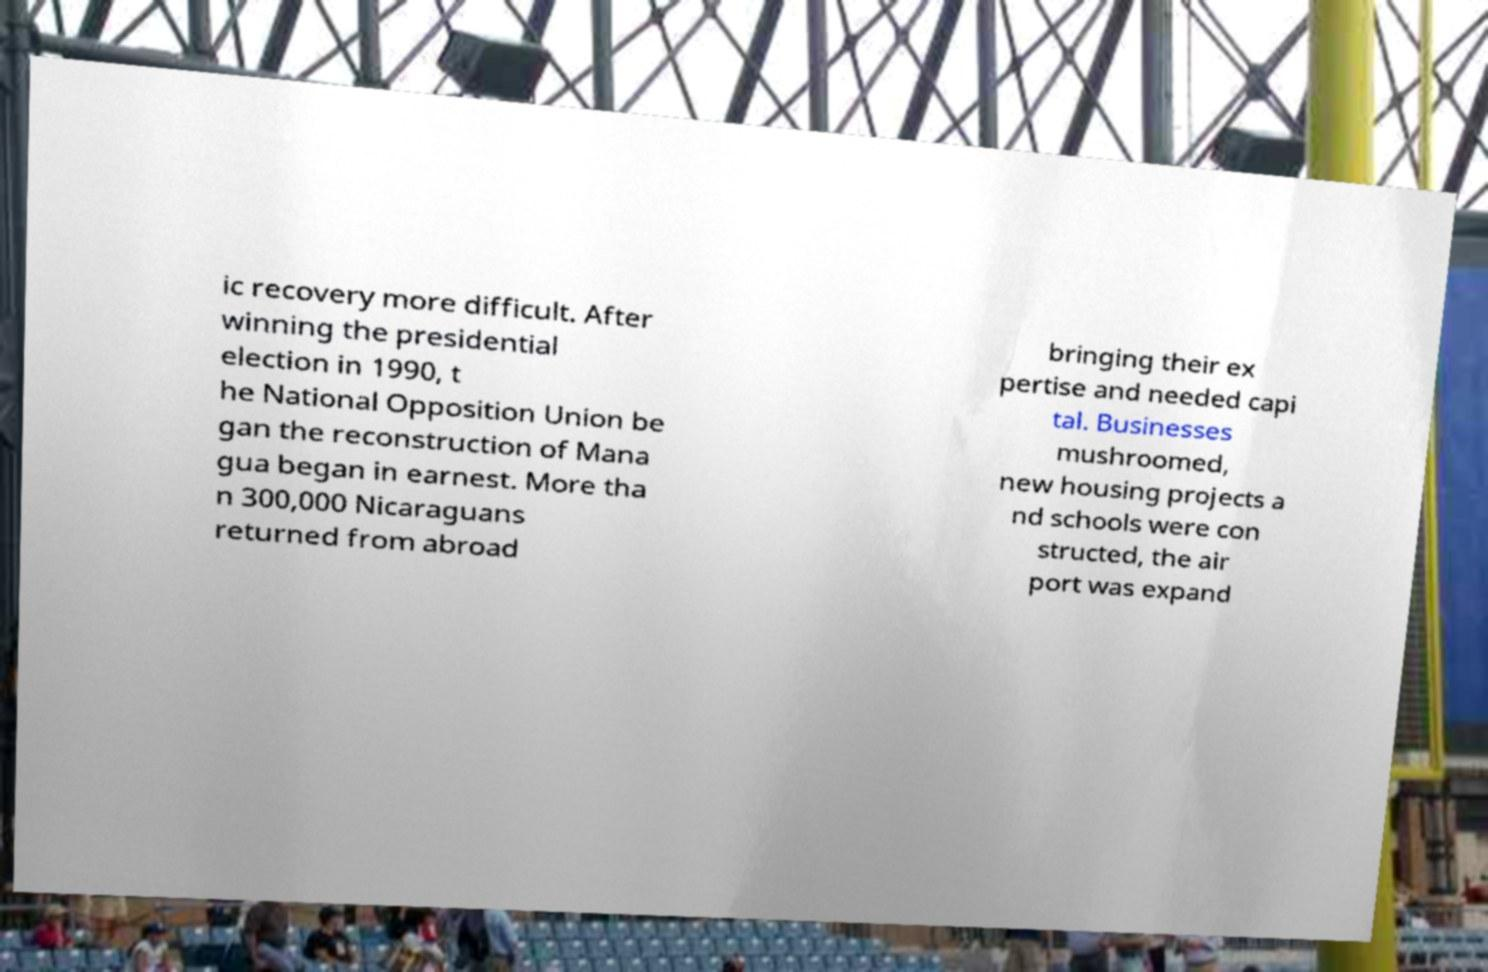There's text embedded in this image that I need extracted. Can you transcribe it verbatim? ic recovery more difficult. After winning the presidential election in 1990, t he National Opposition Union be gan the reconstruction of Mana gua began in earnest. More tha n 300,000 Nicaraguans returned from abroad bringing their ex pertise and needed capi tal. Businesses mushroomed, new housing projects a nd schools were con structed, the air port was expand 